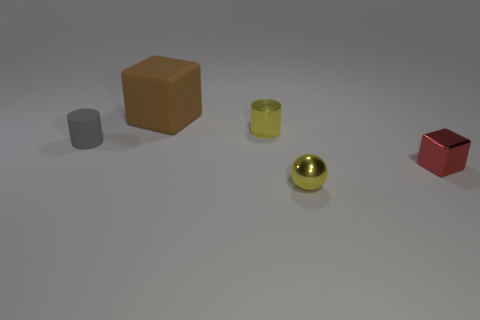Subtract 1 cylinders. How many cylinders are left? 1 Add 4 tiny yellow balls. How many objects exist? 9 Subtract all blocks. How many objects are left? 3 Subtract all blue cylinders. How many purple cubes are left? 0 Subtract all cylinders. Subtract all big brown matte cubes. How many objects are left? 2 Add 5 tiny rubber things. How many tiny rubber things are left? 6 Add 1 matte cylinders. How many matte cylinders exist? 2 Subtract 1 yellow spheres. How many objects are left? 4 Subtract all red cylinders. Subtract all purple spheres. How many cylinders are left? 2 